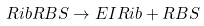<formula> <loc_0><loc_0><loc_500><loc_500>R i b R B S \rightarrow E I R i b + R B S</formula> 